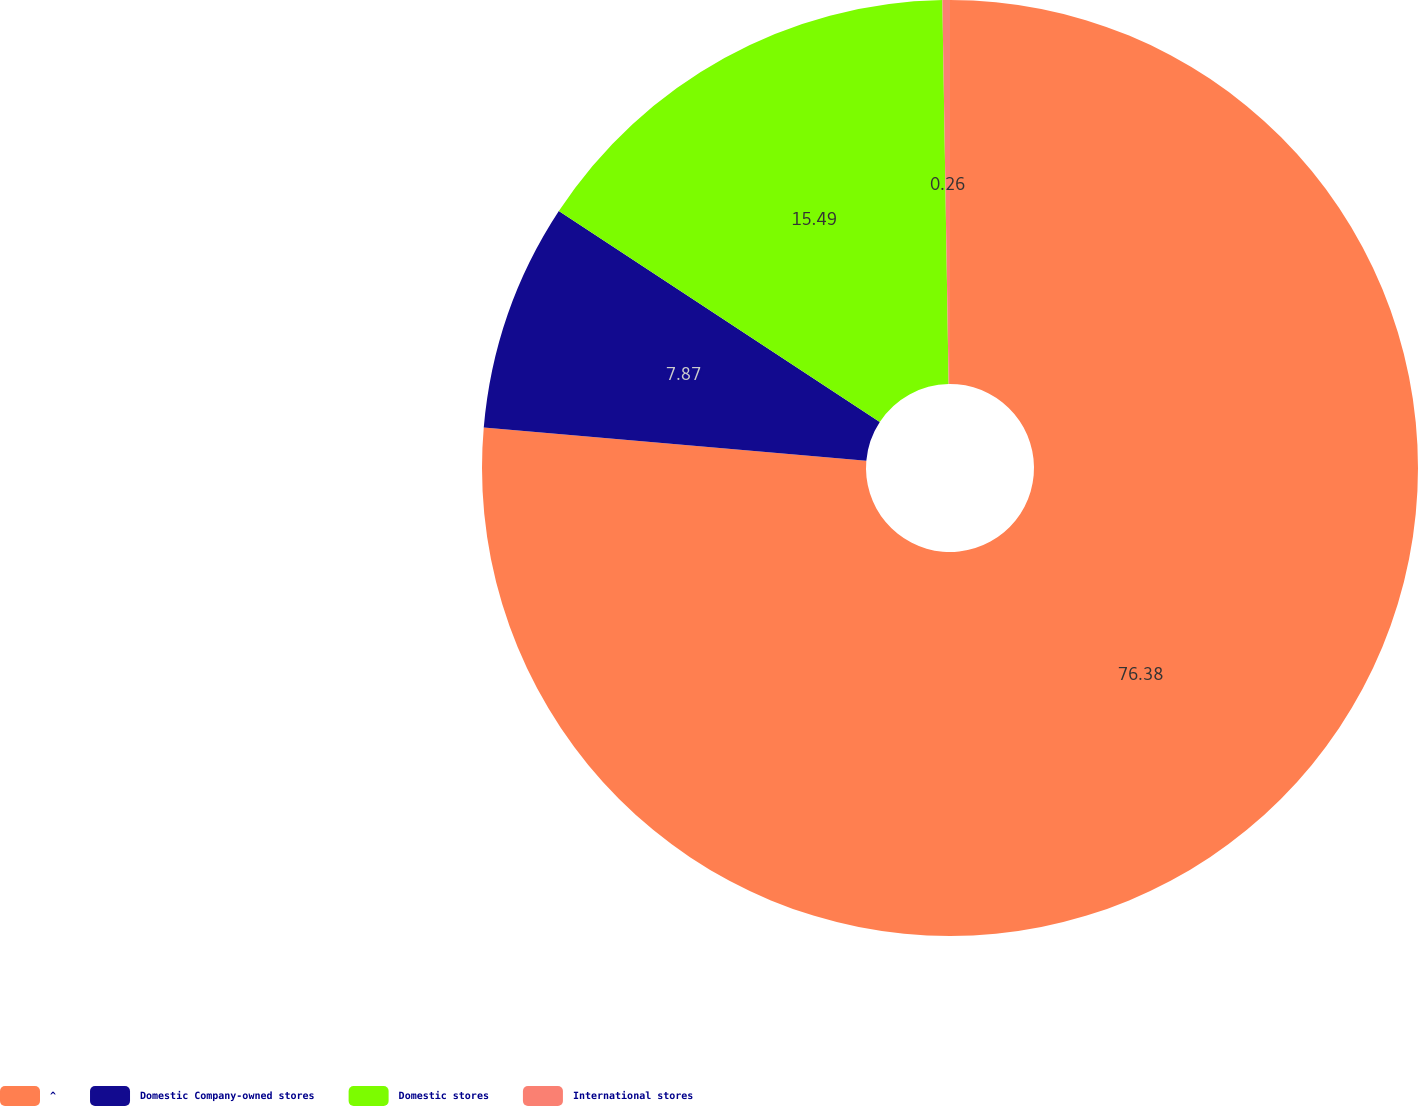Convert chart. <chart><loc_0><loc_0><loc_500><loc_500><pie_chart><fcel>^<fcel>Domestic Company-owned stores<fcel>Domestic stores<fcel>International stores<nl><fcel>76.38%<fcel>7.87%<fcel>15.49%<fcel>0.26%<nl></chart> 